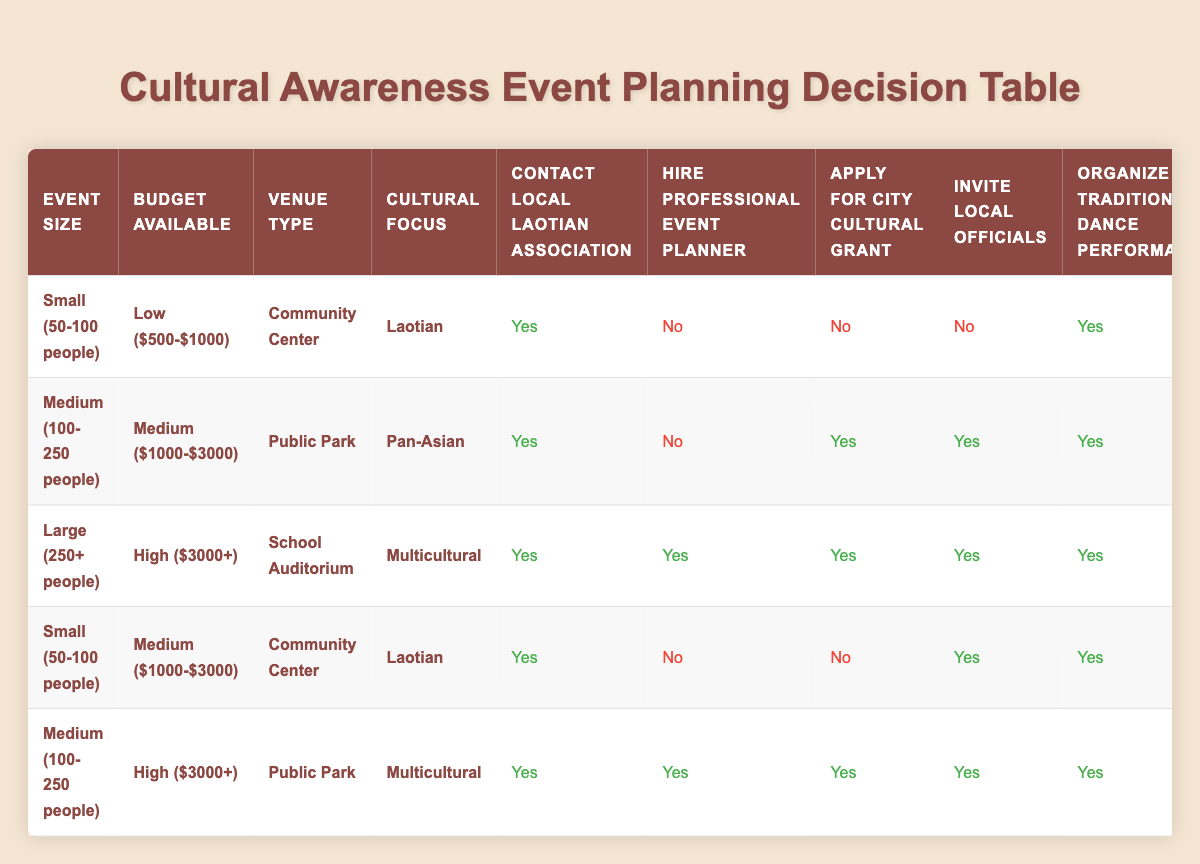What is the venue type for the large event with a high budget? The table shows that for large events (250+ people) with a high budget ($3000+), the venue type listed is "School Auditorium."
Answer: School Auditorium How many actions are taken for a medium-sized event focusing on Laotian culture with a medium budget? For the medium event (100-250 people) focusing on Laotian culture with a medium budget ($1000-$3000), the actions are: Contact Local Laotian Association (Yes), Hire Professional Event Planner (No), Apply for City Cultural Grant (No), Invite Local Officials (Yes), Organize Traditional Dance Performance (Yes), Set Up Food Vendors (Community Volunteers), Create Social Media Campaign (Instagram), and Arrange Language Interpreters (No). Counting the "Yes" responses, there are 4 affirmative actions.
Answer: 4 Are local officials invited for the small event at a community center? Looking at the row for a small event (50-100 people) at a community center focusing on Laotian culture, the table indicates that local officials are not invited, which corresponds to a "No."
Answer: No For a large multicultural event, is there a city cultural grant applied for? The entry for a large event (250+ people), high budget ($3000+), and multicultural focus shows that a city cultural grant is applied for, indicated by a "Yes."
Answer: Yes What is the difference in the number of food vendors between small Laotian events with low and medium budgets? There are two small Laotian events: one with a low budget has food vendors from "Community Volunteers," and the other with a medium budget also lists food vendors as "Community Volunteers." Since both have the same type of food vendors, there is no difference in the number of food vendors.
Answer: 0 For medium-sized events at a public park, how many actions involve hiring or applying for grants? The medium-sized event (100-250 people) at a public park focusing on Pan-Asian culture indicates the following: Hire Professional Event Planner (No) and Apply for City Cultural Grant (Yes). Thus, only one action, the grant application, involves hiring or applying.
Answer: 1 How many total events need interpreters if they are large and multicultural? Referring to the row for large events (250+ people) with a high budget focusing on multicultural, the table states that interpreters are arranged, which is a "Yes." Therefore, one event requires interpreters in this context.
Answer: 1 Which social media platforms are used for events of different sizes? From the data, small Laotian events with low budget use Facebook, medium Pan-Asian events with medium budget use all platforms, large multicultural events use all platforms, and small Laotian events with a medium budget use Instagram. So there are four different instances with varied social media platforms.
Answer: Facebook, All Platforms, All Platforms, Instagram How many actions are common across all large events regardless of cultural focus? In the case of large events, the actions applied are: Contact Local Laotian Association (Yes), Hire Professional Event Planner (Yes), Apply for City Cultural Grant (Yes), Invite Local Officials (Yes), Organize Traditional Dance Performance (Yes), Set Up Food Vendors (Local Restaurants), Create Social Media Campaign (All Platforms), and Arrange Language Interpreters (Yes). Since they all share these "Yes" actions, there are eight common actions across large events.
Answer: 8 